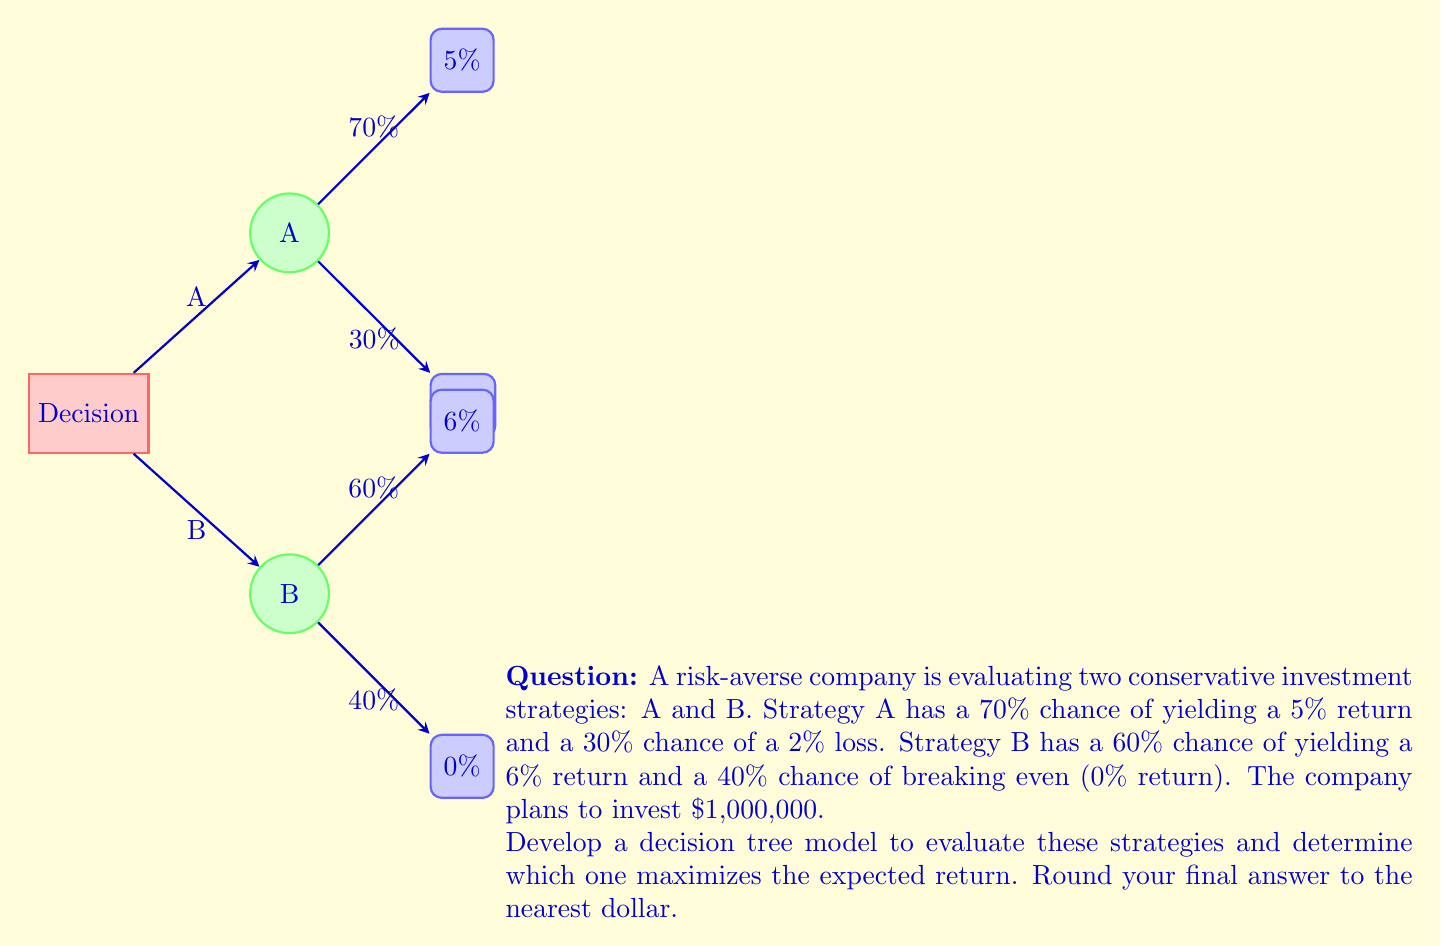Solve this math problem. Let's approach this step-by-step:

1) First, let's calculate the expected return for each strategy:

   Strategy A:
   - 70% chance of 5% return: $0.70 \times 0.05 = 0.035$
   - 30% chance of 2% loss: $0.30 \times (-0.02) = -0.006$
   Expected return A = $0.035 + (-0.006) = 0.029$ or 2.9%

   Strategy B:
   - 60% chance of 6% return: $0.60 \times 0.06 = 0.036$
   - 40% chance of 0% return: $0.40 \times 0 = 0$
   Expected return B = $0.036 + 0 = 0.036$ or 3.6%

2) Now, let's calculate the expected monetary value for each strategy given the $1,000,000 investment:

   Strategy A: $1,000,000 \times 0.029 = $29,000
   Strategy B: $1,000,000 \times 0.036 = $36,000

3) The decision tree model can be represented as follows:

   ```
   Investment Decision
   |
   |-- Strategy A (Expected Return: 2.9%)
   |   |-- 70% chance: 5% return
   |   |-- 30% chance: 2% loss
   |
   |-- Strategy B (Expected Return: 3.6%)
       |-- 60% chance: 6% return
       |-- 40% chance: 0% return
   ```

4) Based on the expected returns, Strategy B maximizes the expected return with $36,000.
Answer: $36,000 